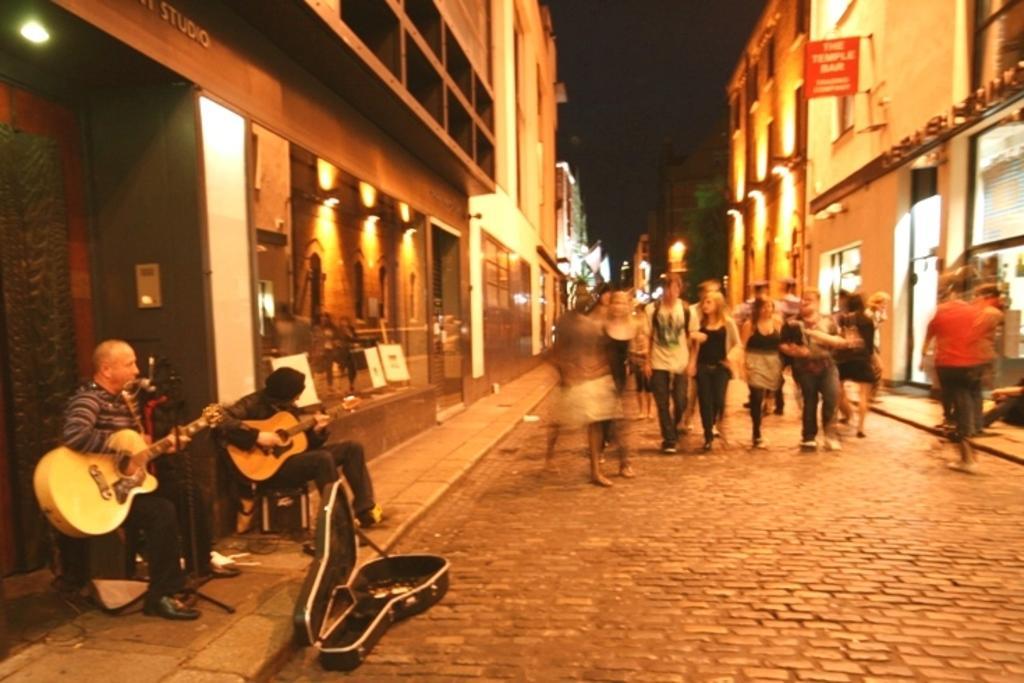Can you describe this image briefly? There are group of people walking on the street. Here are two people sitting and playing guitar. This is a guitar box which is black in color. These are the buildings. I can see a red color banner hanging to the hanger. At background i can see a tree. 